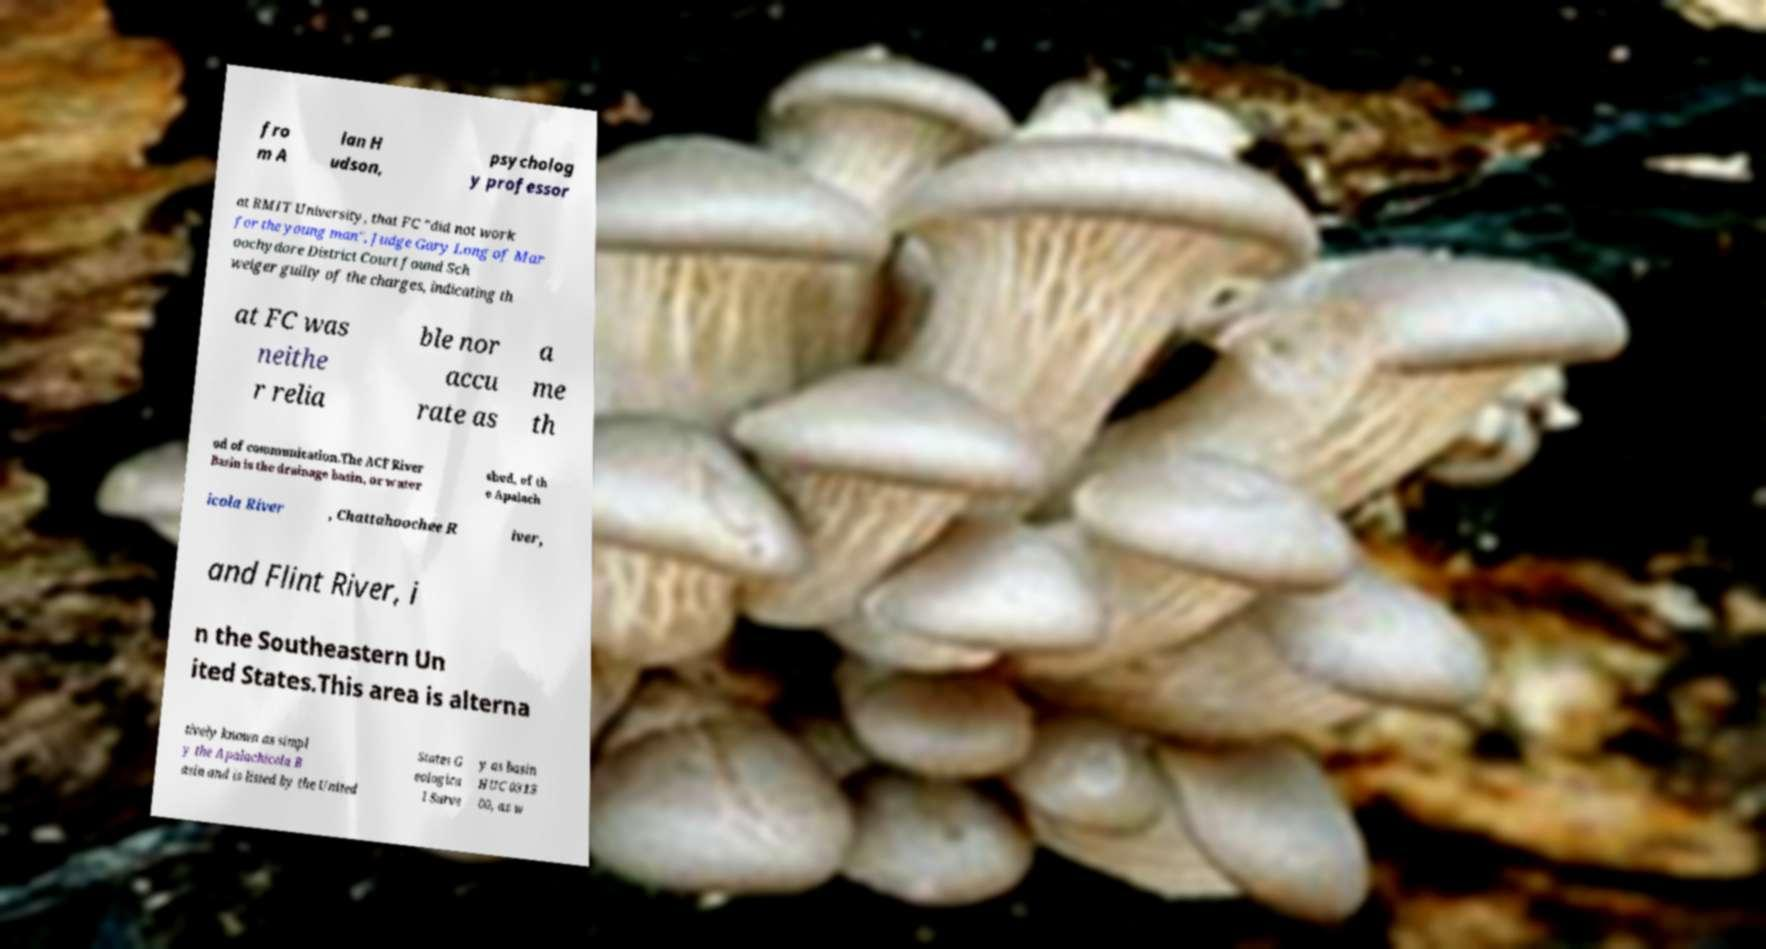What messages or text are displayed in this image? I need them in a readable, typed format. fro m A lan H udson, psycholog y professor at RMIT University, that FC "did not work for the young man", Judge Gary Long of Mar oochydore District Court found Sch weiger guilty of the charges, indicating th at FC was neithe r relia ble nor accu rate as a me th od of communication.The ACF River Basin is the drainage basin, or water shed, of th e Apalach icola River , Chattahoochee R iver, and Flint River, i n the Southeastern Un ited States.This area is alterna tively known as simpl y the Apalachicola B asin and is listed by the United States G eologica l Surve y as basin HUC 0313 00, as w 